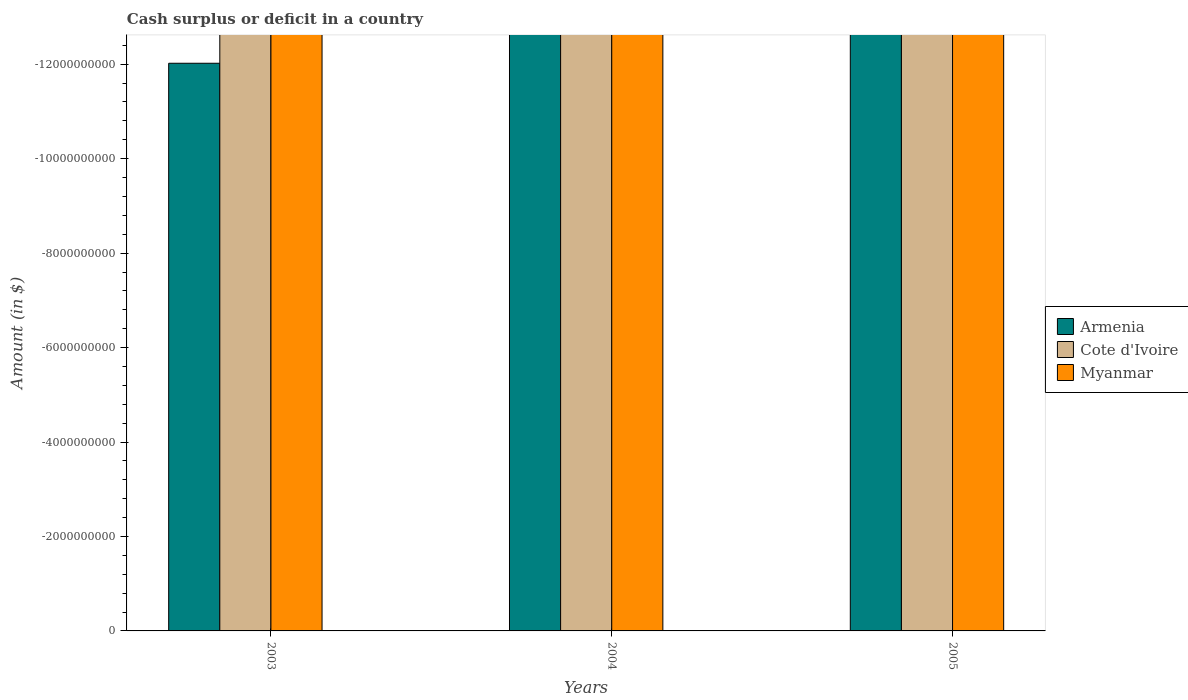How many different coloured bars are there?
Offer a terse response. 0. Are the number of bars per tick equal to the number of legend labels?
Your response must be concise. No. Are the number of bars on each tick of the X-axis equal?
Offer a very short reply. Yes. How many bars are there on the 3rd tick from the right?
Keep it short and to the point. 0. Across all years, what is the minimum amount of cash surplus or deficit in Myanmar?
Provide a succinct answer. 0. What is the total amount of cash surplus or deficit in Armenia in the graph?
Ensure brevity in your answer.  0. How many bars are there?
Offer a very short reply. 0. Are all the bars in the graph horizontal?
Offer a very short reply. No. How many years are there in the graph?
Keep it short and to the point. 3. What is the difference between two consecutive major ticks on the Y-axis?
Make the answer very short. 2.00e+09. Does the graph contain any zero values?
Your response must be concise. Yes. Does the graph contain grids?
Keep it short and to the point. No. How many legend labels are there?
Make the answer very short. 3. What is the title of the graph?
Offer a very short reply. Cash surplus or deficit in a country. What is the label or title of the X-axis?
Provide a short and direct response. Years. What is the label or title of the Y-axis?
Offer a very short reply. Amount (in $). What is the Amount (in $) of Armenia in 2003?
Your answer should be very brief. 0. What is the Amount (in $) in Cote d'Ivoire in 2004?
Make the answer very short. 0. What is the Amount (in $) of Myanmar in 2004?
Offer a very short reply. 0. What is the Amount (in $) in Myanmar in 2005?
Provide a short and direct response. 0. What is the total Amount (in $) of Myanmar in the graph?
Offer a very short reply. 0. What is the average Amount (in $) of Myanmar per year?
Ensure brevity in your answer.  0. 